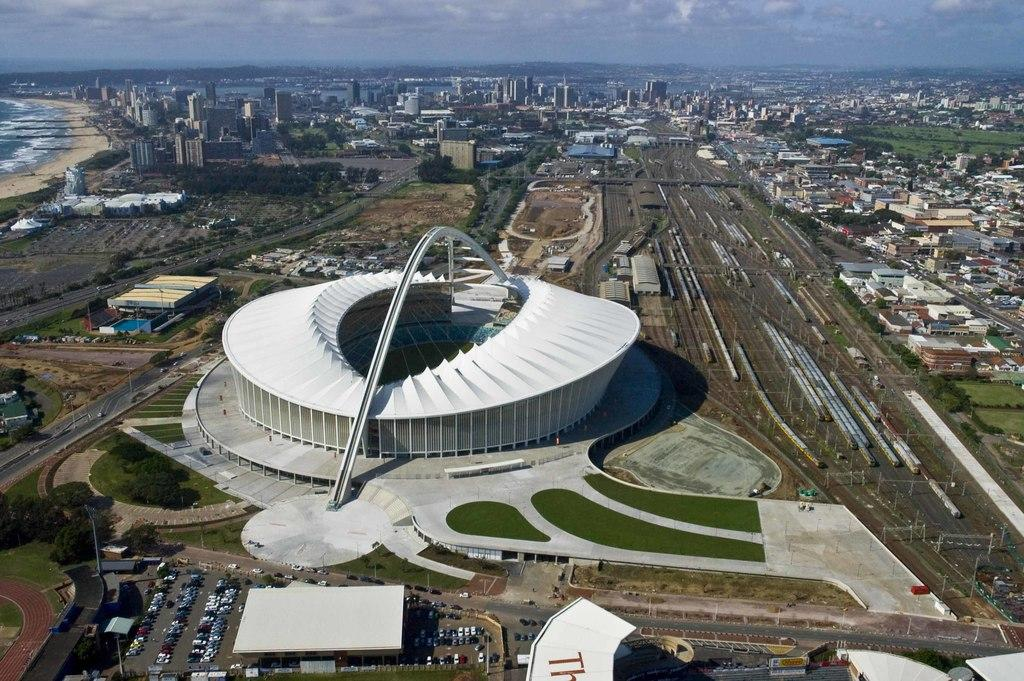What type of structures can be seen in the image? There are buildings in the image. What else is present in the image besides buildings? There are vehicles, trees, and poles visible in the image. What can be seen in the background of the image? There is water visible in the background of the image. What type of box is being used for arithmetic calculations in the image? There is no box or arithmetic calculations present in the image. How much dirt can be seen on the vehicles in the image? There is no dirt visible on the vehicles in the image. 